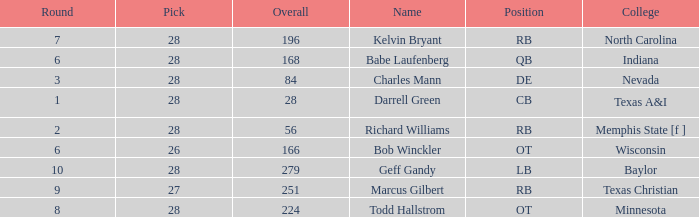What is the highest pick of the player from texas a&i with an overall less than 28? None. 